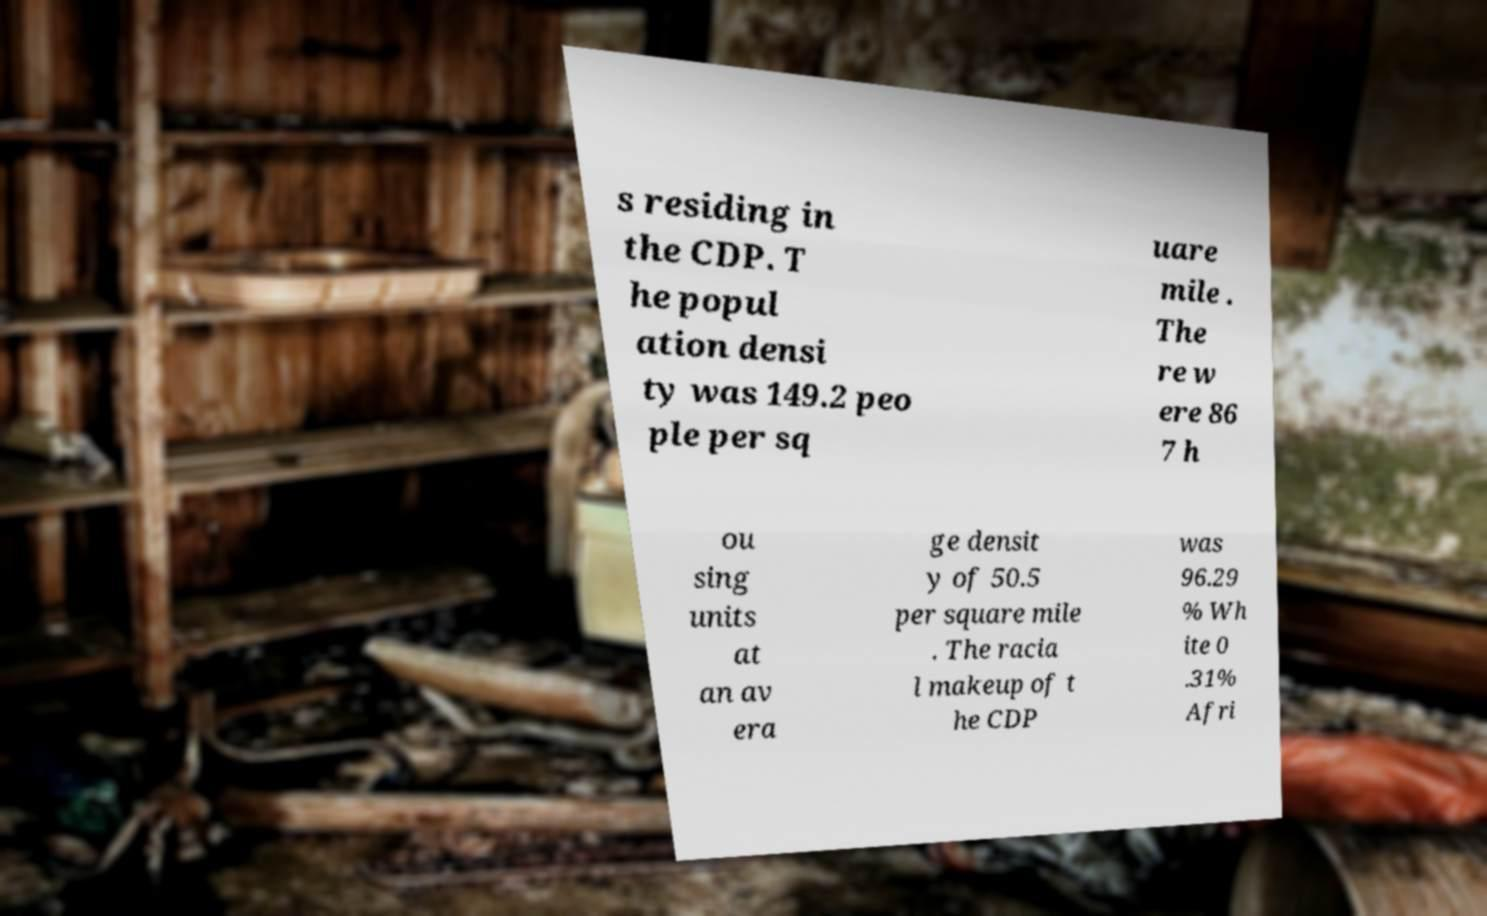Can you accurately transcribe the text from the provided image for me? s residing in the CDP. T he popul ation densi ty was 149.2 peo ple per sq uare mile . The re w ere 86 7 h ou sing units at an av era ge densit y of 50.5 per square mile . The racia l makeup of t he CDP was 96.29 % Wh ite 0 .31% Afri 